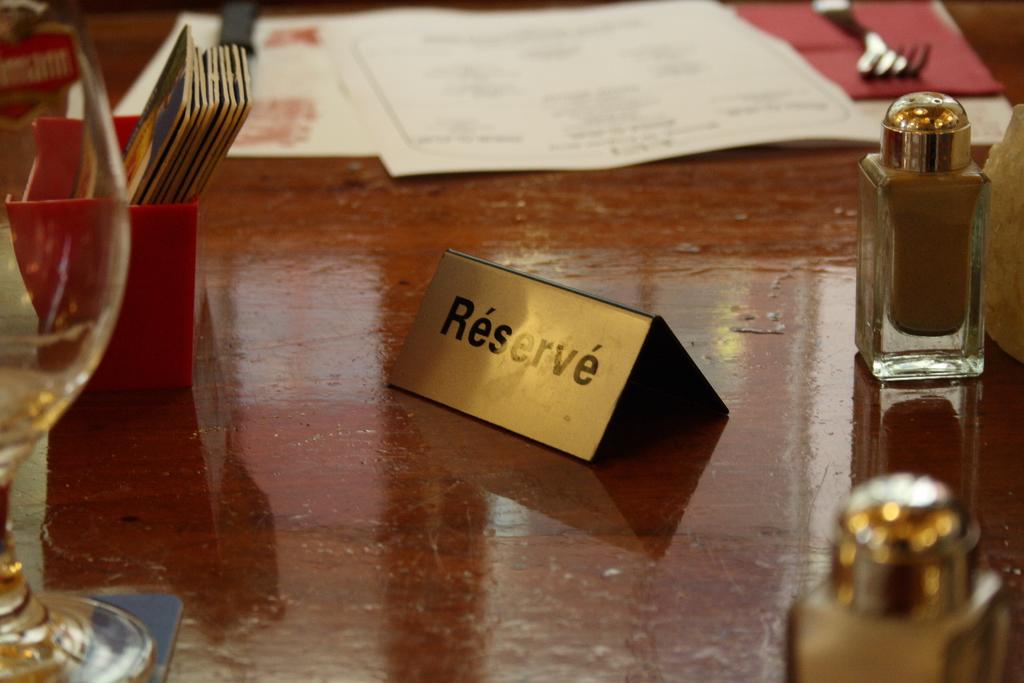What word is on the nametag thing?
Ensure brevity in your answer.  Reserve. 